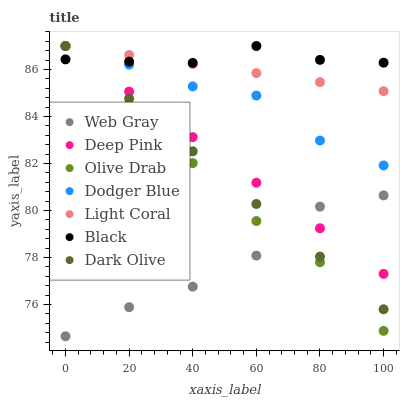Does Web Gray have the minimum area under the curve?
Answer yes or no. Yes. Does Black have the maximum area under the curve?
Answer yes or no. Yes. Does Dark Olive have the minimum area under the curve?
Answer yes or no. No. Does Dark Olive have the maximum area under the curve?
Answer yes or no. No. Is Dark Olive the smoothest?
Answer yes or no. Yes. Is Web Gray the roughest?
Answer yes or no. Yes. Is Light Coral the smoothest?
Answer yes or no. No. Is Light Coral the roughest?
Answer yes or no. No. Does Web Gray have the lowest value?
Answer yes or no. Yes. Does Dark Olive have the lowest value?
Answer yes or no. No. Does Olive Drab have the highest value?
Answer yes or no. Yes. Is Web Gray less than Dodger Blue?
Answer yes or no. Yes. Is Dodger Blue greater than Web Gray?
Answer yes or no. Yes. Does Light Coral intersect Olive Drab?
Answer yes or no. Yes. Is Light Coral less than Olive Drab?
Answer yes or no. No. Is Light Coral greater than Olive Drab?
Answer yes or no. No. Does Web Gray intersect Dodger Blue?
Answer yes or no. No. 